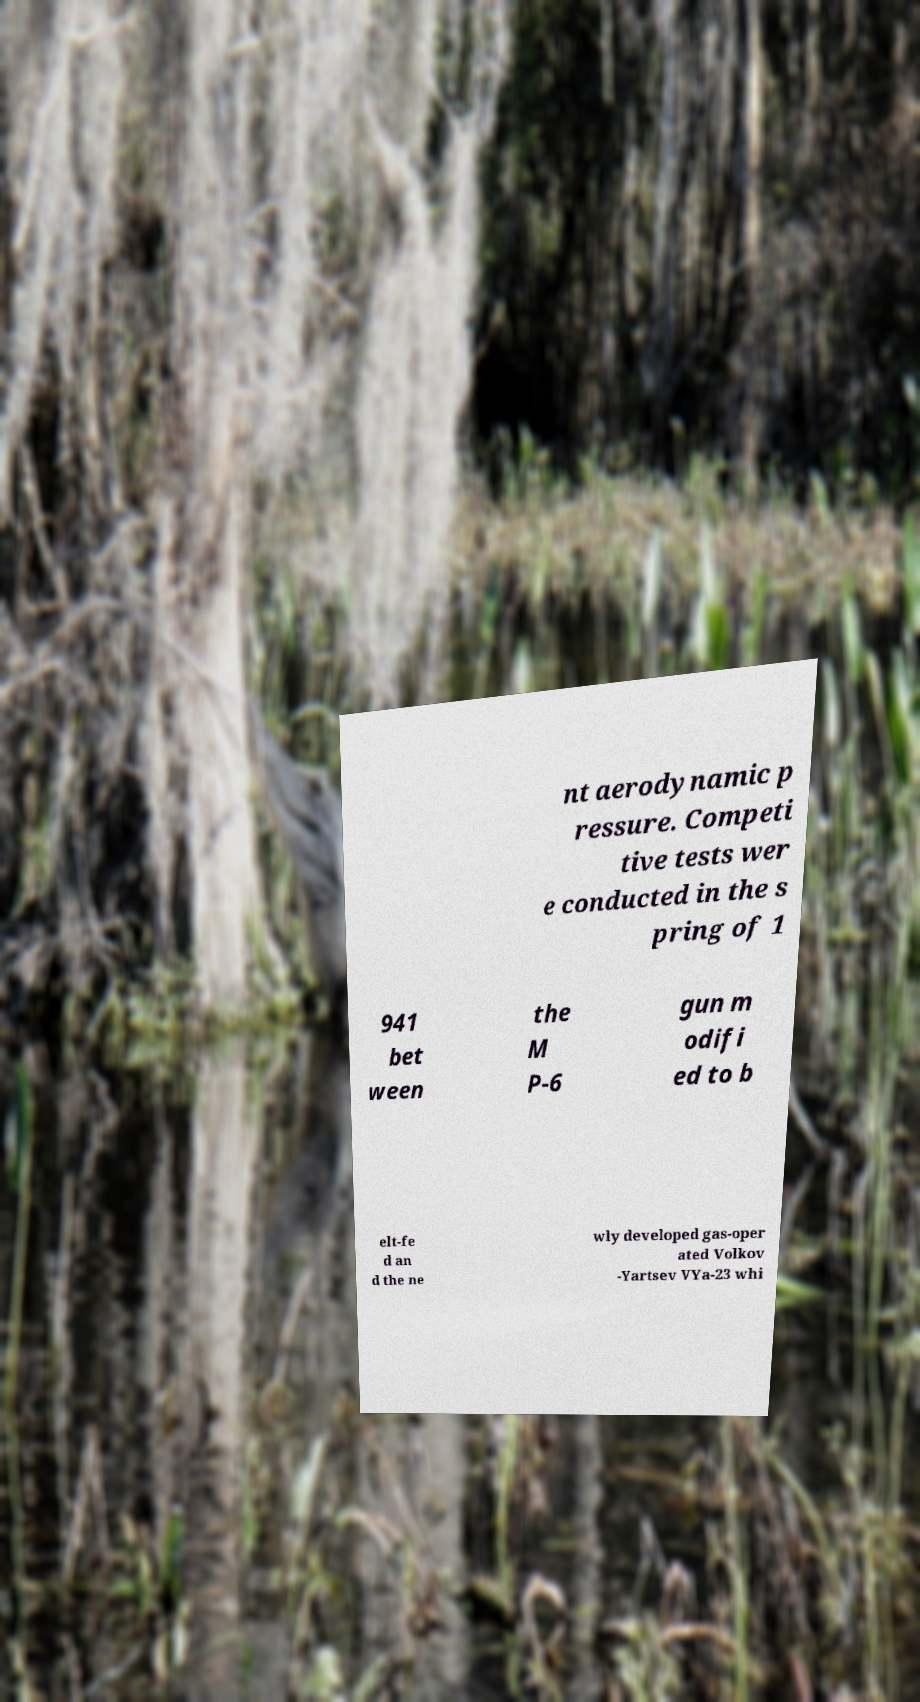For documentation purposes, I need the text within this image transcribed. Could you provide that? nt aerodynamic p ressure. Competi tive tests wer e conducted in the s pring of 1 941 bet ween the M P-6 gun m odifi ed to b elt-fe d an d the ne wly developed gas-oper ated Volkov -Yartsev VYa-23 whi 